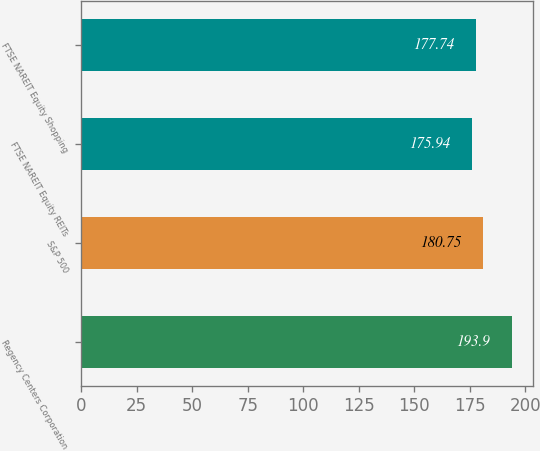Convert chart to OTSL. <chart><loc_0><loc_0><loc_500><loc_500><bar_chart><fcel>Regency Centers Corporation<fcel>S&P 500<fcel>FTSE NAREIT Equity REITs<fcel>FTSE NAREIT Equity Shopping<nl><fcel>193.9<fcel>180.75<fcel>175.94<fcel>177.74<nl></chart> 